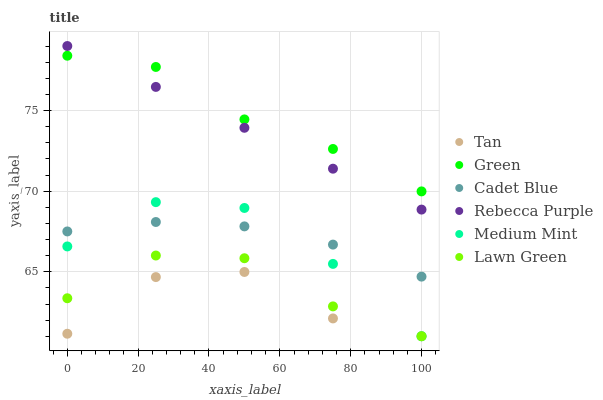Does Tan have the minimum area under the curve?
Answer yes or no. Yes. Does Green have the maximum area under the curve?
Answer yes or no. Yes. Does Lawn Green have the minimum area under the curve?
Answer yes or no. No. Does Lawn Green have the maximum area under the curve?
Answer yes or no. No. Is Rebecca Purple the smoothest?
Answer yes or no. Yes. Is Tan the roughest?
Answer yes or no. Yes. Is Lawn Green the smoothest?
Answer yes or no. No. Is Lawn Green the roughest?
Answer yes or no. No. Does Medium Mint have the lowest value?
Answer yes or no. Yes. Does Cadet Blue have the lowest value?
Answer yes or no. No. Does Rebecca Purple have the highest value?
Answer yes or no. Yes. Does Lawn Green have the highest value?
Answer yes or no. No. Is Tan less than Rebecca Purple?
Answer yes or no. Yes. Is Rebecca Purple greater than Tan?
Answer yes or no. Yes. Does Green intersect Rebecca Purple?
Answer yes or no. Yes. Is Green less than Rebecca Purple?
Answer yes or no. No. Is Green greater than Rebecca Purple?
Answer yes or no. No. Does Tan intersect Rebecca Purple?
Answer yes or no. No. 